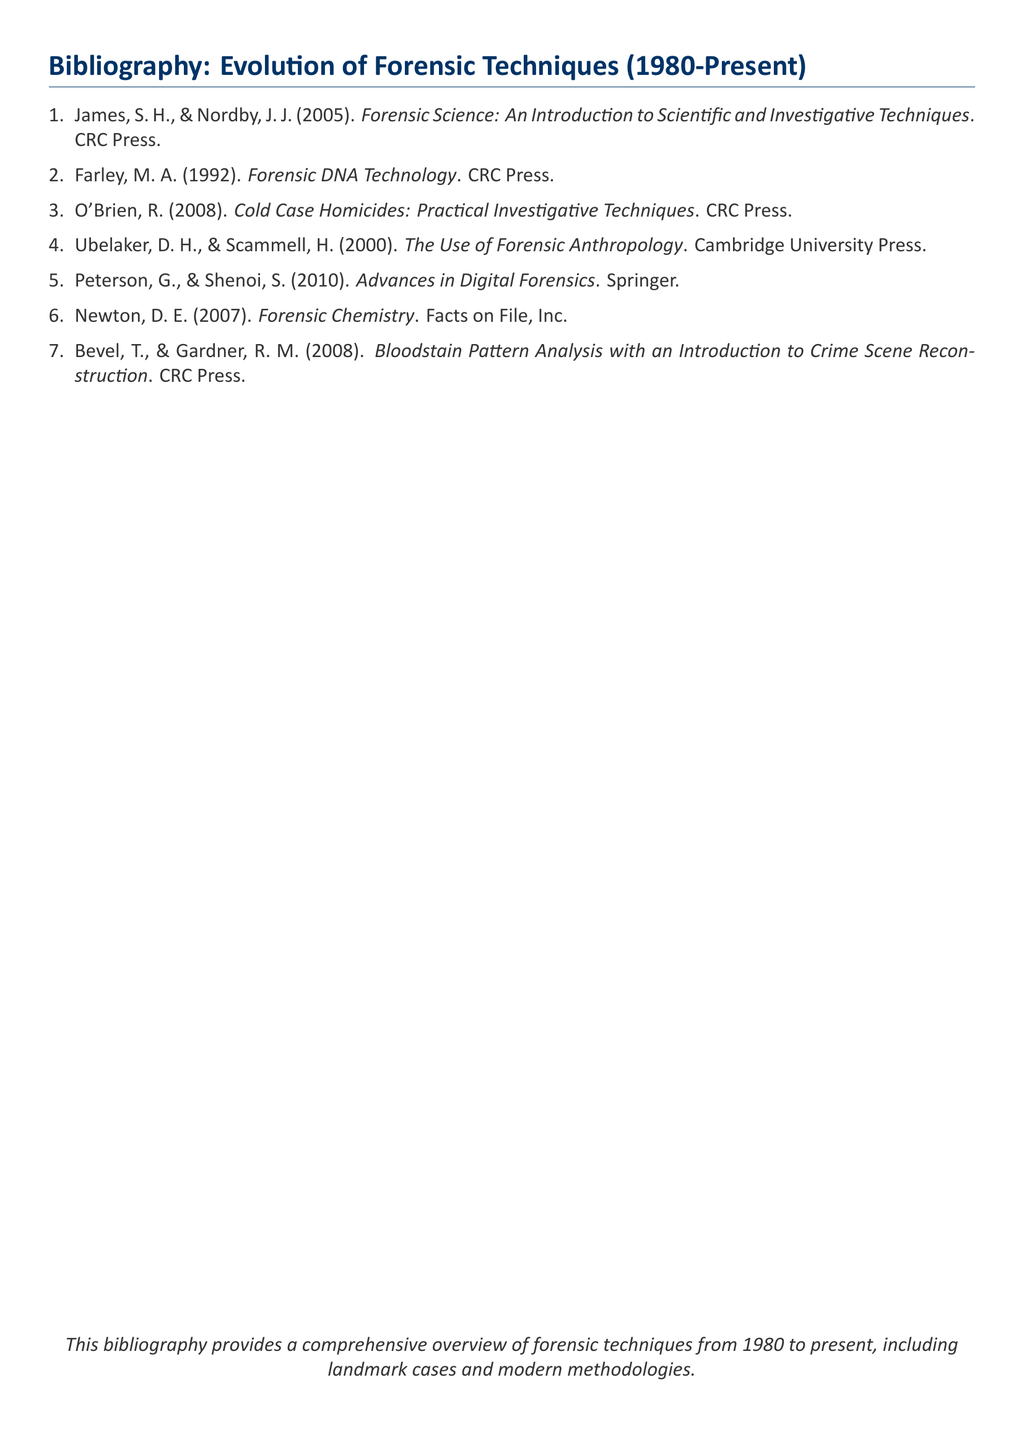What is the title of the first listed work in the bibliography? The first work in the bibliography is titled "Forensic Science: An Introduction to Scientific and Investigative Techniques."
Answer: Forensic Science: An Introduction to Scientific and Investigative Techniques Who are the authors of the work titled "Advances in Digital Forensics"? This work is authored by G. Peterson and S. Shenoi, as mentioned in the bibliography.
Answer: G. Peterson and S. Shenoi In what year was "Cold Case Homicides: Practical Investigative Techniques" published? According to the bibliography, this work was published in 2008.
Answer: 2008 Which publishing company released "Forensic DNA Technology"? The document states that CRC Press is the publisher of this work.
Answer: CRC Press How many works authored by Ubelaker are listed in the bibliography? The bibliography includes one work authored by Ubelaker, which is "The Use of Forensic Anthropology."
Answer: One 